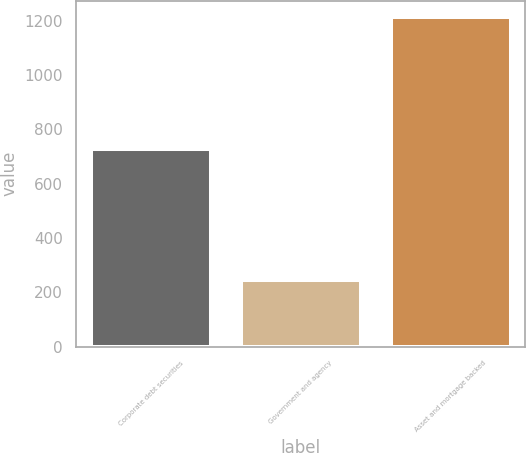Convert chart. <chart><loc_0><loc_0><loc_500><loc_500><bar_chart><fcel>Corporate debt securities<fcel>Government and agency<fcel>Asset and mortgage backed<nl><fcel>727<fcel>244<fcel>1212<nl></chart> 